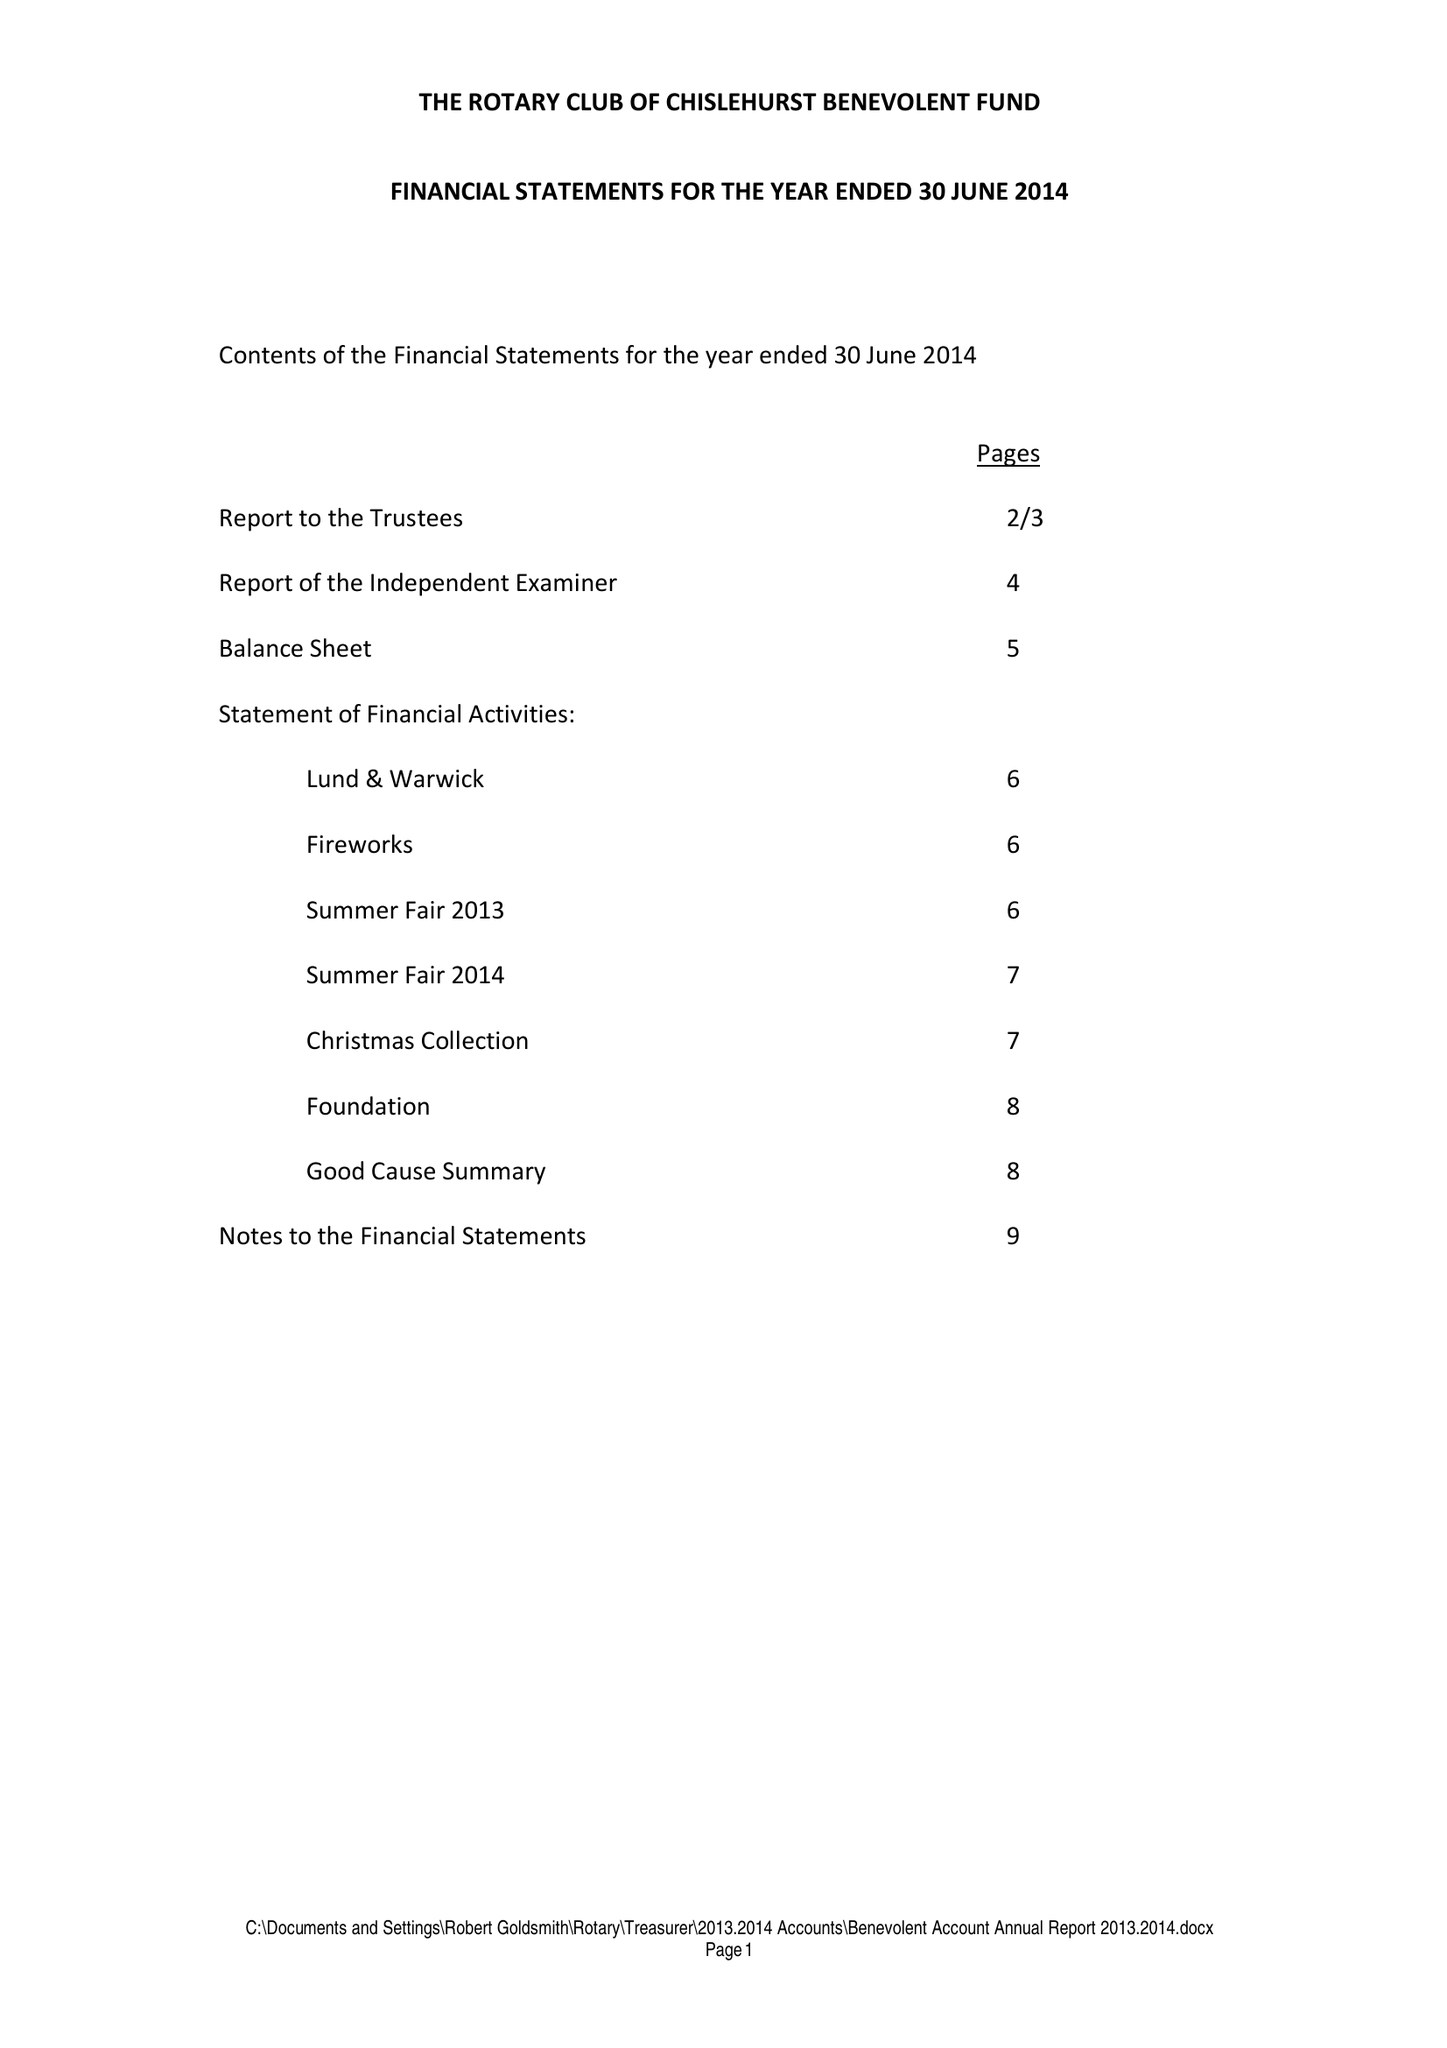What is the value for the income_annually_in_british_pounds?
Answer the question using a single word or phrase. 32043.00 